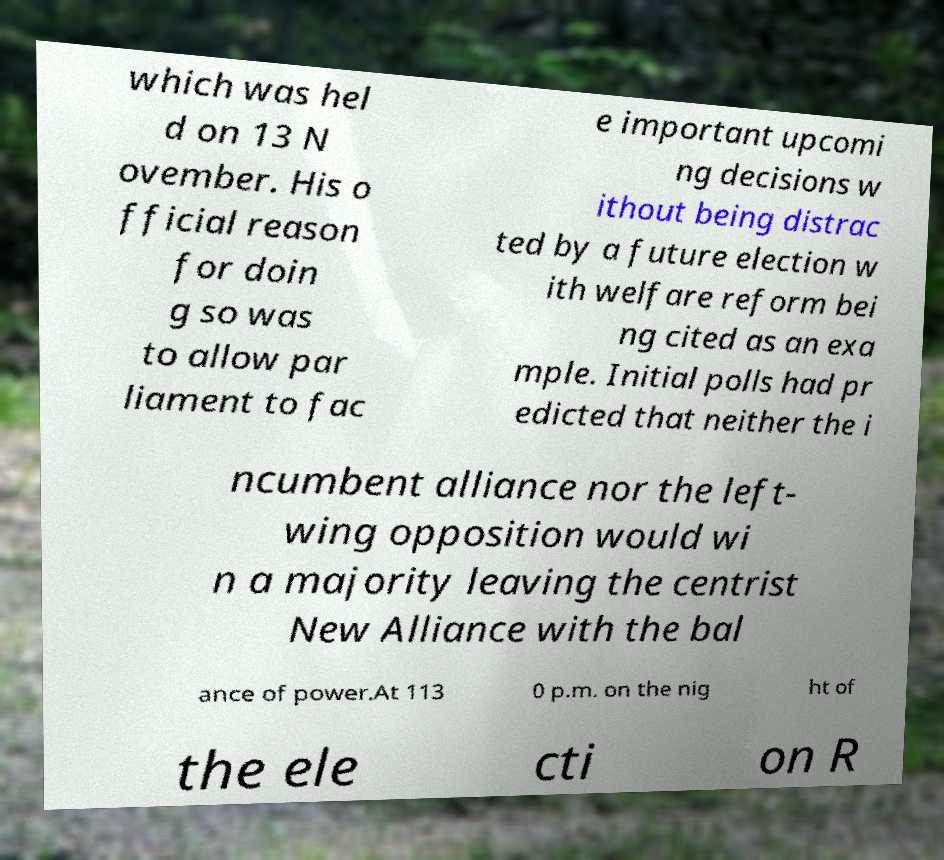Can you read and provide the text displayed in the image?This photo seems to have some interesting text. Can you extract and type it out for me? which was hel d on 13 N ovember. His o fficial reason for doin g so was to allow par liament to fac e important upcomi ng decisions w ithout being distrac ted by a future election w ith welfare reform bei ng cited as an exa mple. Initial polls had pr edicted that neither the i ncumbent alliance nor the left- wing opposition would wi n a majority leaving the centrist New Alliance with the bal ance of power.At 113 0 p.m. on the nig ht of the ele cti on R 